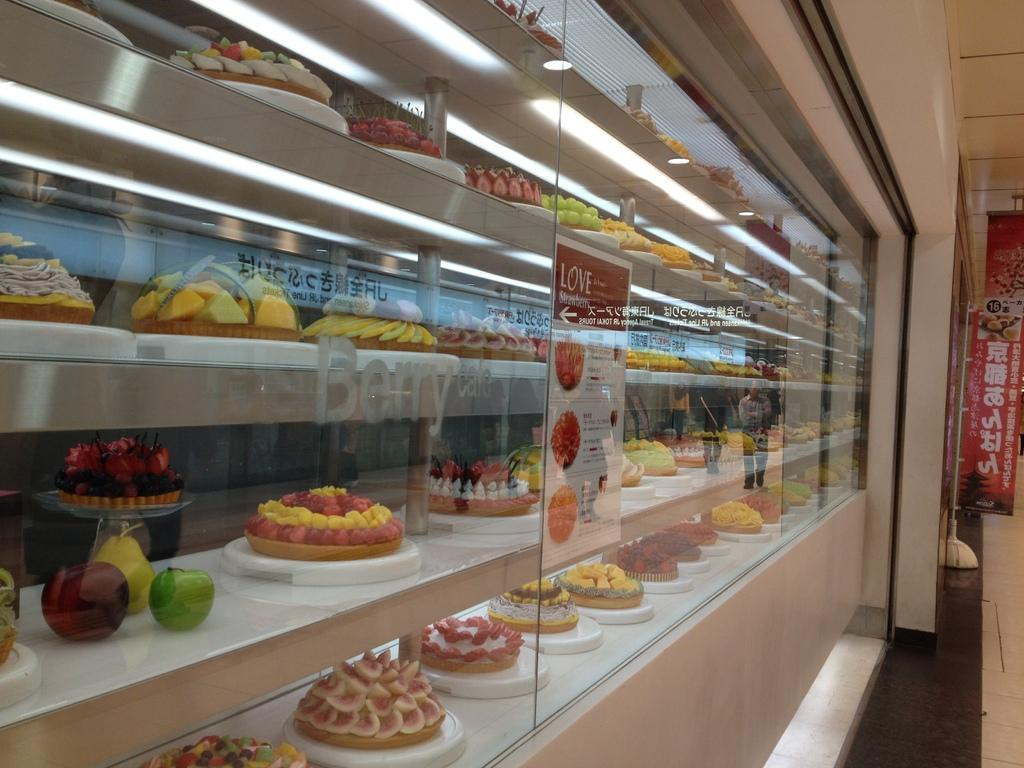<image>
Provide a brief description of the given image. A poster on a display case of desserts reaches out to those who "Love Strawberry". 